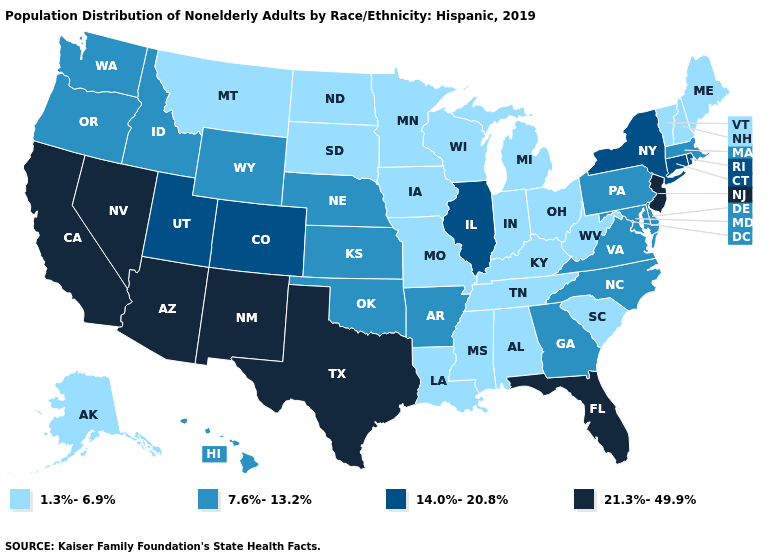Which states have the lowest value in the South?
Answer briefly. Alabama, Kentucky, Louisiana, Mississippi, South Carolina, Tennessee, West Virginia. Name the states that have a value in the range 14.0%-20.8%?
Be succinct. Colorado, Connecticut, Illinois, New York, Rhode Island, Utah. Name the states that have a value in the range 14.0%-20.8%?
Quick response, please. Colorado, Connecticut, Illinois, New York, Rhode Island, Utah. Name the states that have a value in the range 14.0%-20.8%?
Concise answer only. Colorado, Connecticut, Illinois, New York, Rhode Island, Utah. Which states have the lowest value in the USA?
Answer briefly. Alabama, Alaska, Indiana, Iowa, Kentucky, Louisiana, Maine, Michigan, Minnesota, Mississippi, Missouri, Montana, New Hampshire, North Dakota, Ohio, South Carolina, South Dakota, Tennessee, Vermont, West Virginia, Wisconsin. What is the lowest value in the USA?
Give a very brief answer. 1.3%-6.9%. What is the highest value in states that border Massachusetts?
Answer briefly. 14.0%-20.8%. Does Indiana have the lowest value in the MidWest?
Quick response, please. Yes. Which states have the lowest value in the USA?
Quick response, please. Alabama, Alaska, Indiana, Iowa, Kentucky, Louisiana, Maine, Michigan, Minnesota, Mississippi, Missouri, Montana, New Hampshire, North Dakota, Ohio, South Carolina, South Dakota, Tennessee, Vermont, West Virginia, Wisconsin. Which states have the lowest value in the Northeast?
Concise answer only. Maine, New Hampshire, Vermont. What is the value of Arkansas?
Concise answer only. 7.6%-13.2%. Name the states that have a value in the range 21.3%-49.9%?
Give a very brief answer. Arizona, California, Florida, Nevada, New Jersey, New Mexico, Texas. What is the value of Louisiana?
Quick response, please. 1.3%-6.9%. Among the states that border Virginia , does North Carolina have the lowest value?
Answer briefly. No. Does the map have missing data?
Write a very short answer. No. 